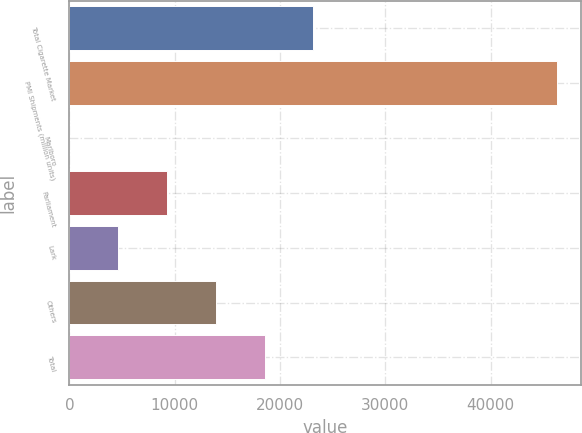<chart> <loc_0><loc_0><loc_500><loc_500><bar_chart><fcel>Total Cigarette Market<fcel>PMI Shipments (million units)<fcel>Marlboro<fcel>Parliament<fcel>Lark<fcel>Others<fcel>Total<nl><fcel>23158.8<fcel>46309<fcel>8.6<fcel>9268.68<fcel>4638.64<fcel>13898.7<fcel>18528.8<nl></chart> 